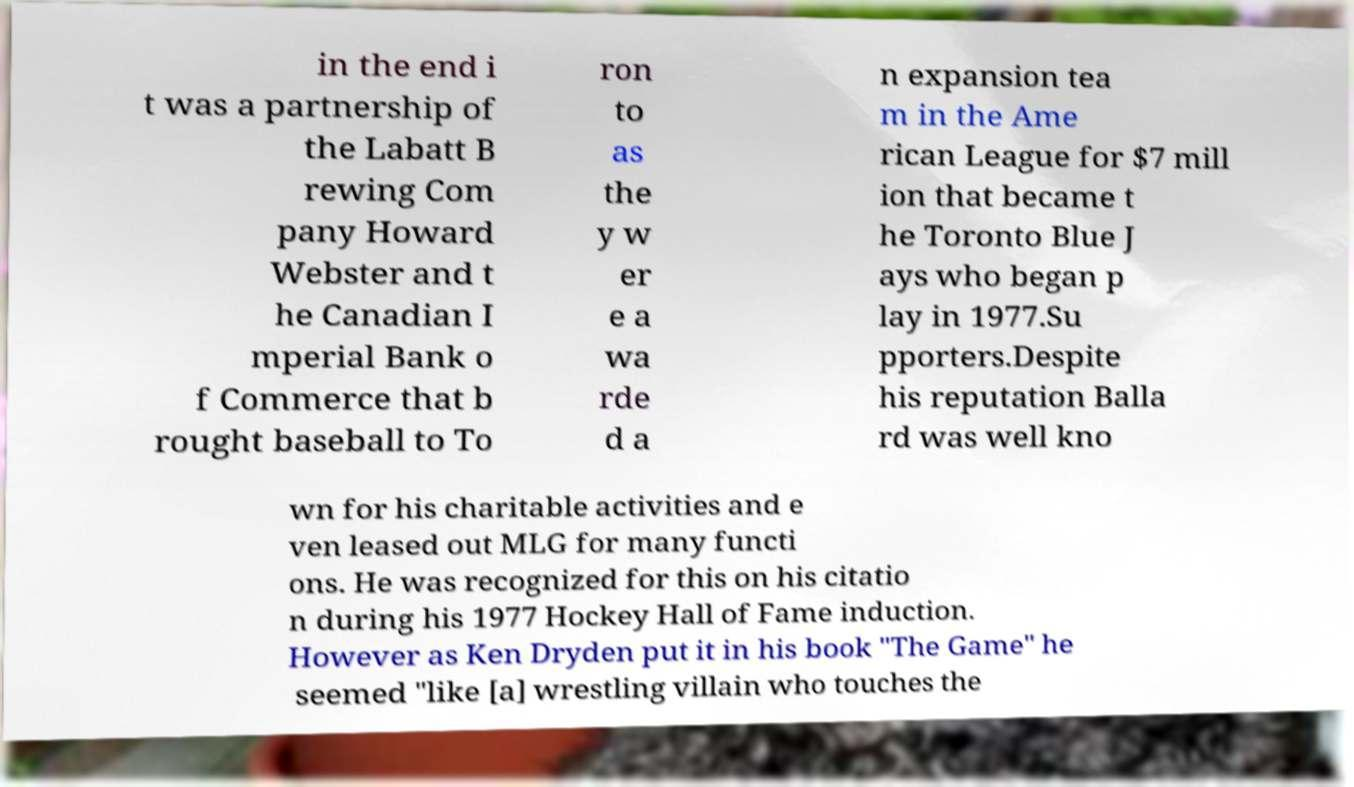Please identify and transcribe the text found in this image. in the end i t was a partnership of the Labatt B rewing Com pany Howard Webster and t he Canadian I mperial Bank o f Commerce that b rought baseball to To ron to as the y w er e a wa rde d a n expansion tea m in the Ame rican League for $7 mill ion that became t he Toronto Blue J ays who began p lay in 1977.Su pporters.Despite his reputation Balla rd was well kno wn for his charitable activities and e ven leased out MLG for many functi ons. He was recognized for this on his citatio n during his 1977 Hockey Hall of Fame induction. However as Ken Dryden put it in his book "The Game" he seemed "like [a] wrestling villain who touches the 